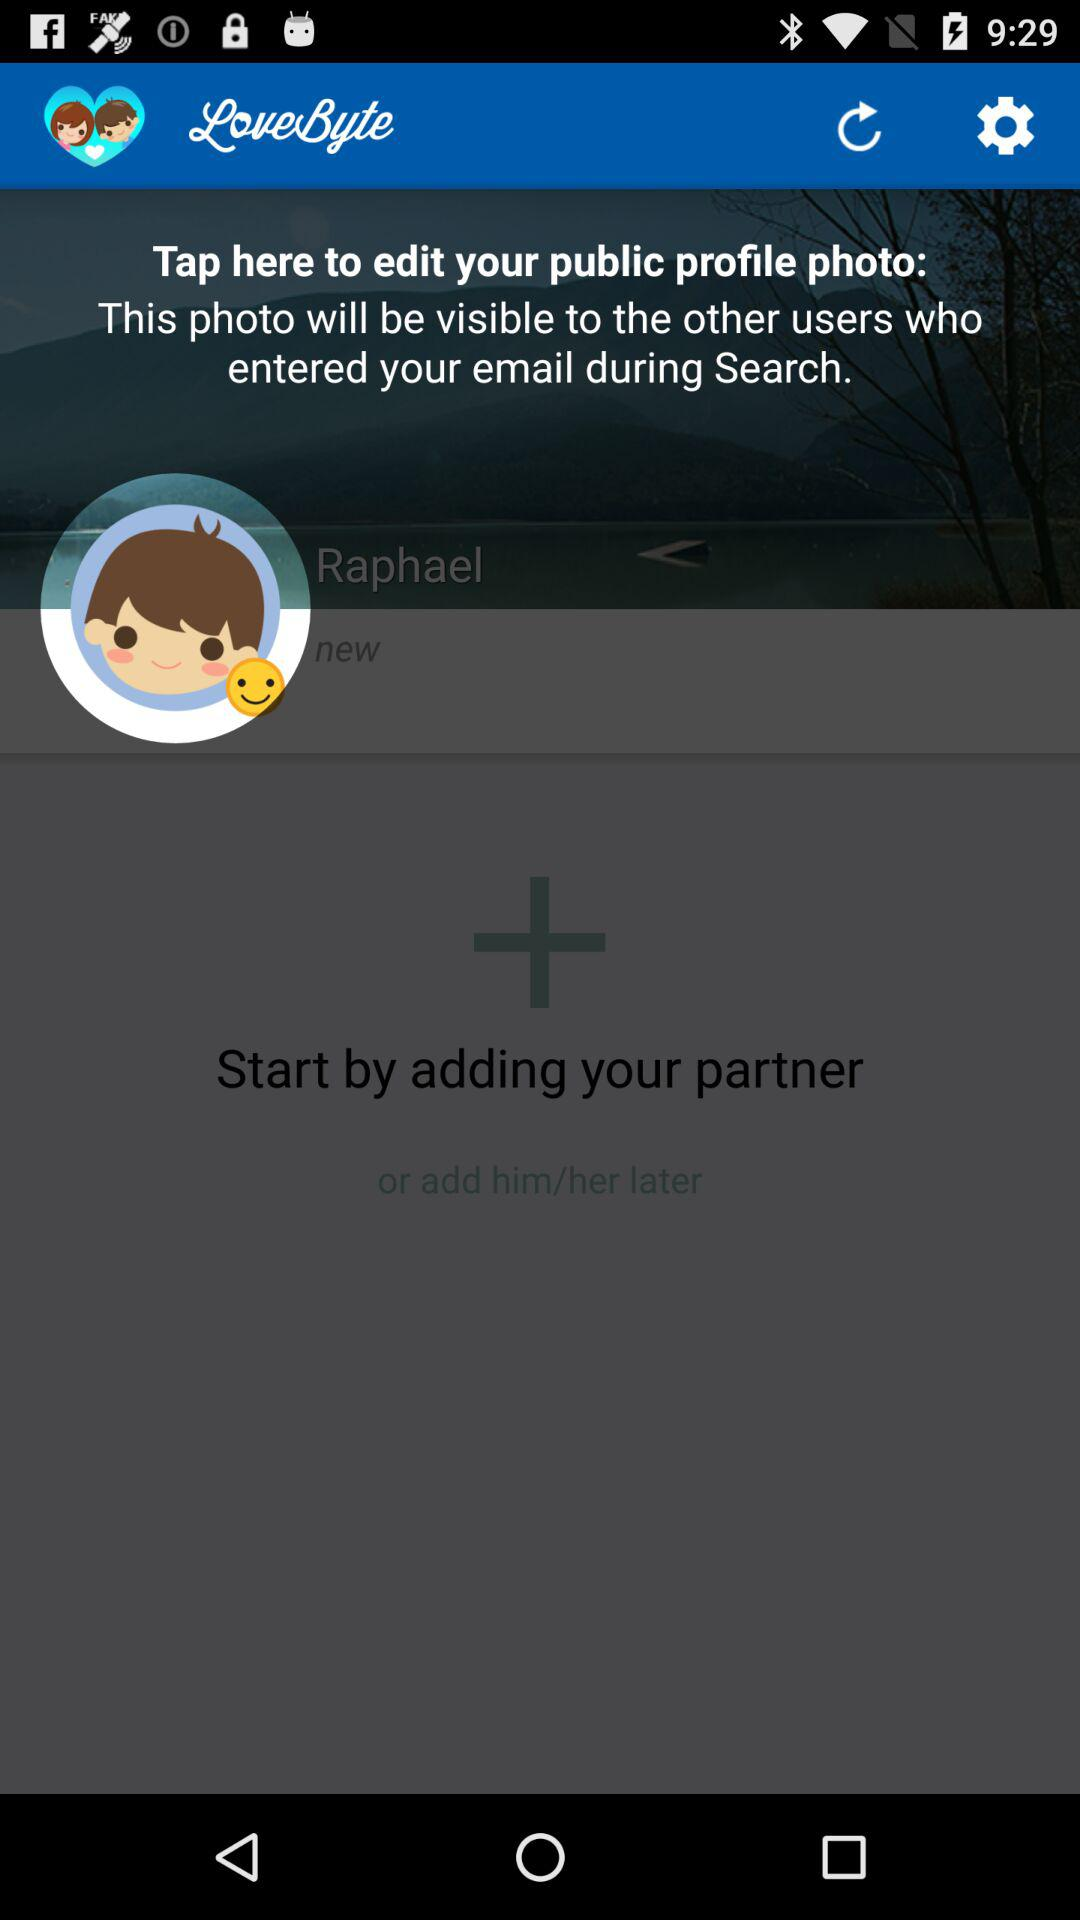What is the name of the application? The name of the application is "LoveByte". 